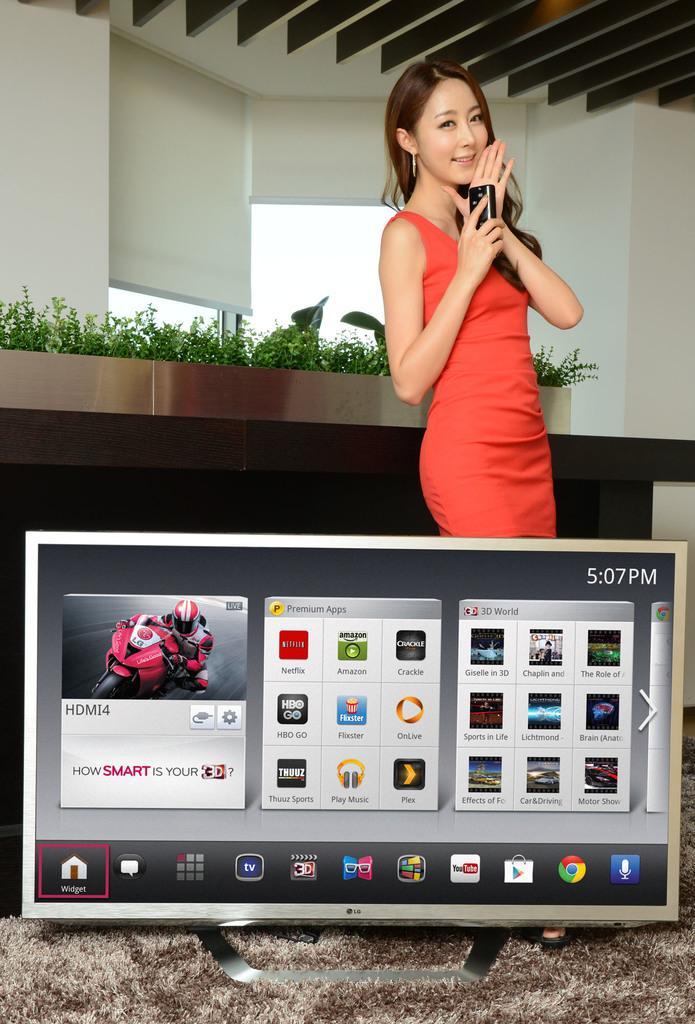Could you give a brief overview of what you see in this image? In this image I can see the screen and the person with an orange color dress. In the background I can see the plants and the window blinds. 